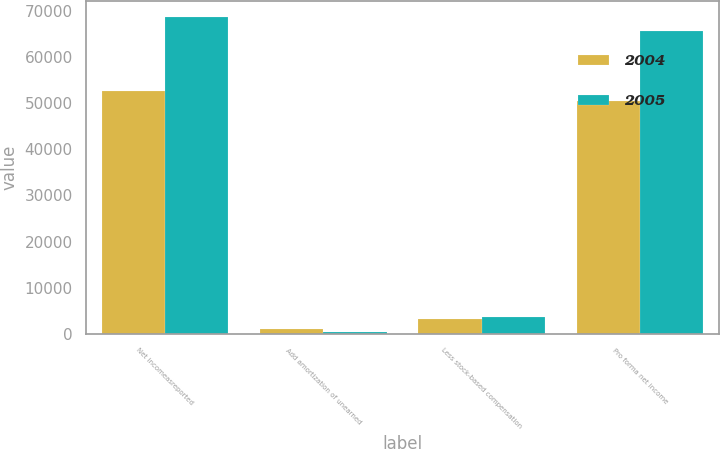<chart> <loc_0><loc_0><loc_500><loc_500><stacked_bar_chart><ecel><fcel>Net incomeasreported<fcel>Add amortization of unearned<fcel>Less stock-based compensation<fcel>Pro forma net income<nl><fcel>2004<fcel>52604<fcel>1016<fcel>3224<fcel>50396<nl><fcel>2005<fcel>68730<fcel>403<fcel>3575<fcel>65558<nl></chart> 